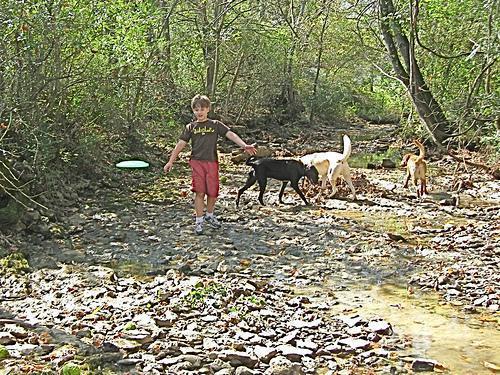How many dogs?
Give a very brief answer. 3. How many people?
Give a very brief answer. 1. How many animals in picture?
Give a very brief answer. 3. 